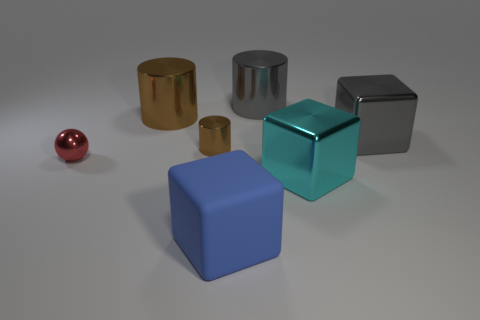Subtract all green blocks. How many brown cylinders are left? 2 Subtract all metal blocks. How many blocks are left? 1 Add 2 gray metal blocks. How many objects exist? 9 Subtract 1 cylinders. How many cylinders are left? 2 Subtract all spheres. How many objects are left? 6 Subtract 0 green spheres. How many objects are left? 7 Subtract all small cyan metal blocks. Subtract all gray metal things. How many objects are left? 5 Add 3 brown cylinders. How many brown cylinders are left? 5 Add 3 large gray matte cylinders. How many large gray matte cylinders exist? 3 